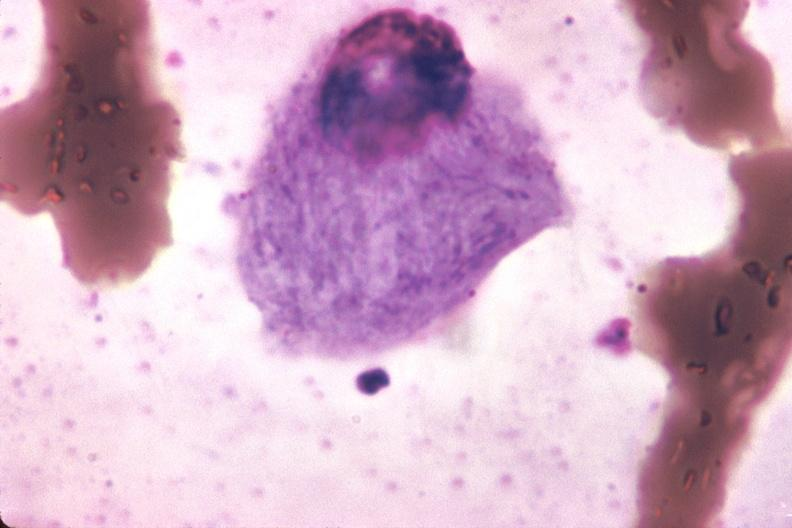s hematologic present?
Answer the question using a single word or phrase. Yes 